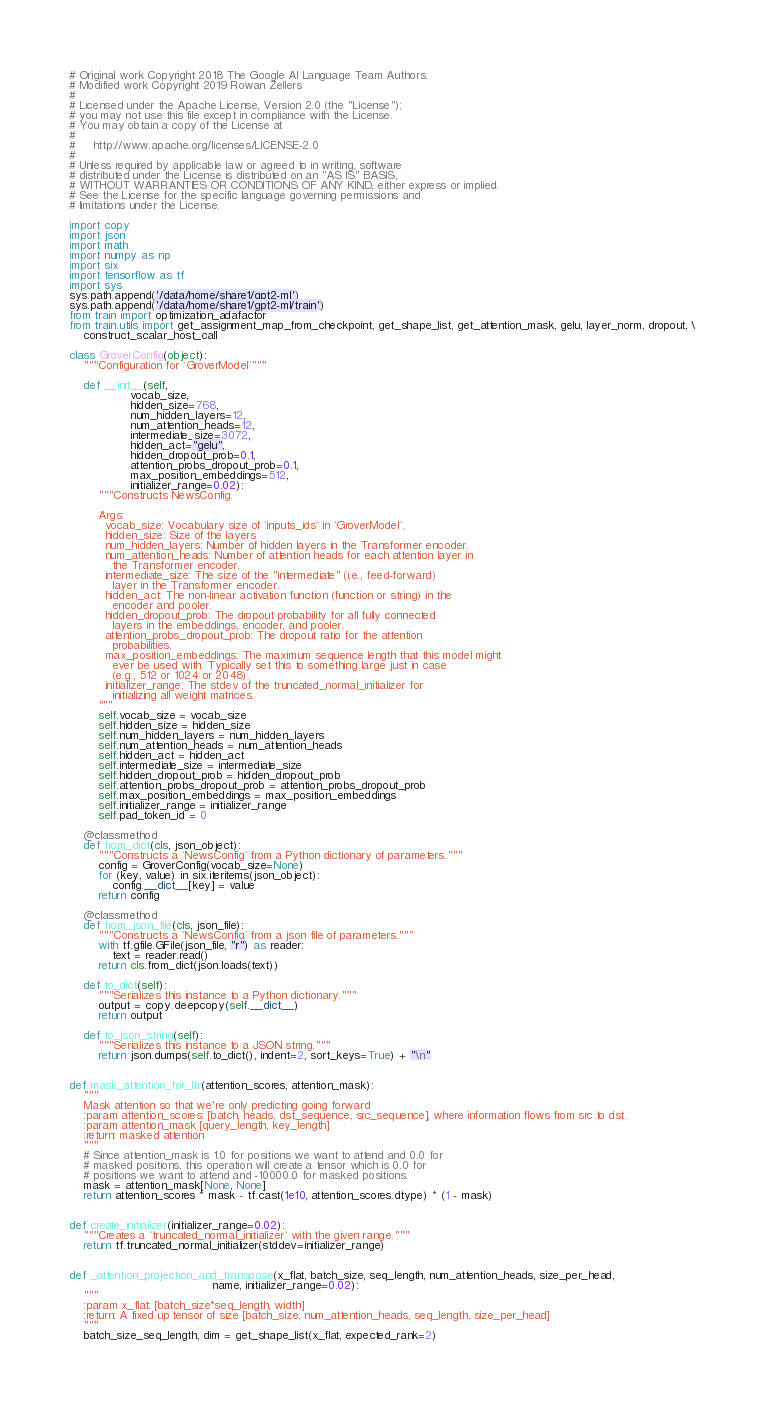Convert code to text. <code><loc_0><loc_0><loc_500><loc_500><_Python_># Original work Copyright 2018 The Google AI Language Team Authors.
# Modified work Copyright 2019 Rowan Zellers
#
# Licensed under the Apache License, Version 2.0 (the "License");
# you may not use this file except in compliance with the License.
# You may obtain a copy of the License at
#
#     http://www.apache.org/licenses/LICENSE-2.0
#
# Unless required by applicable law or agreed to in writing, software
# distributed under the License is distributed on an "AS IS" BASIS,
# WITHOUT WARRANTIES OR CONDITIONS OF ANY KIND, either express or implied.
# See the License for the specific language governing permissions and
# limitations under the License.

import copy
import json
import math
import numpy as np
import six
import tensorflow as tf
import sys
sys.path.append('/data/home/share1/gpt2-ml')
sys.path.append('/data/home/share1/gpt2-ml/train')
from train import optimization_adafactor
from train.utils import get_assignment_map_from_checkpoint, get_shape_list, get_attention_mask, gelu, layer_norm, dropout, \
    construct_scalar_host_call

class GroverConfig(object):
    """Configuration for `GroverModel`"""

    def __init__(self,
                 vocab_size,
                 hidden_size=768,
                 num_hidden_layers=12,
                 num_attention_heads=12,
                 intermediate_size=3072,
                 hidden_act="gelu",
                 hidden_dropout_prob=0.1,
                 attention_probs_dropout_prob=0.1,
                 max_position_embeddings=512,
                 initializer_range=0.02):
        """Constructs NewsConfig.

        Args:
          vocab_size: Vocabulary size of `inputs_ids` in `GroverModel`.
          hidden_size: Size of the layers
          num_hidden_layers: Number of hidden layers in the Transformer encoder.
          num_attention_heads: Number of attention heads for each attention layer in
            the Transformer encoder.
          intermediate_size: The size of the "intermediate" (i.e., feed-forward)
            layer in the Transformer encoder.
          hidden_act: The non-linear activation function (function or string) in the
            encoder and pooler.
          hidden_dropout_prob: The dropout probability for all fully connected
            layers in the embeddings, encoder, and pooler.
          attention_probs_dropout_prob: The dropout ratio for the attention
            probabilities.
          max_position_embeddings: The maximum sequence length that this model might
            ever be used with. Typically set this to something large just in case
            (e.g., 512 or 1024 or 2048).
          initializer_range: The stdev of the truncated_normal_initializer for
            initializing all weight matrices.
        """
        self.vocab_size = vocab_size
        self.hidden_size = hidden_size
        self.num_hidden_layers = num_hidden_layers
        self.num_attention_heads = num_attention_heads
        self.hidden_act = hidden_act
        self.intermediate_size = intermediate_size
        self.hidden_dropout_prob = hidden_dropout_prob
        self.attention_probs_dropout_prob = attention_probs_dropout_prob
        self.max_position_embeddings = max_position_embeddings
        self.initializer_range = initializer_range
        self.pad_token_id = 0

    @classmethod
    def from_dict(cls, json_object):
        """Constructs a `NewsConfig` from a Python dictionary of parameters."""
        config = GroverConfig(vocab_size=None)
        for (key, value) in six.iteritems(json_object):
            config.__dict__[key] = value
        return config

    @classmethod
    def from_json_file(cls, json_file):
        """Constructs a `NewsConfig` from a json file of parameters."""
        with tf.gfile.GFile(json_file, "r") as reader:
            text = reader.read()
        return cls.from_dict(json.loads(text))

    def to_dict(self):
        """Serializes this instance to a Python dictionary."""
        output = copy.deepcopy(self.__dict__)
        return output

    def to_json_string(self):
        """Serializes this instance to a JSON string."""
        return json.dumps(self.to_dict(), indent=2, sort_keys=True) + "\n"


def mask_attention_for_ltr(attention_scores, attention_mask):
    """
    Mask attention so that we're only predicting going forward
    :param attention_scores: [batch, heads, dst_sequence, src_sequence], where information flows from src to dst.
    :param attention_mask [query_length, key_length]
    :return: masked attention
    """
    # Since attention_mask is 1.0 for positions we want to attend and 0.0 for
    # masked positions, this operation will create a tensor which is 0.0 for
    # positions we want to attend and -10000.0 for masked positions.
    mask = attention_mask[None, None]
    return attention_scores * mask - tf.cast(1e10, attention_scores.dtype) * (1 - mask)


def create_initializer(initializer_range=0.02):
    """Creates a `truncated_normal_initializer` with the given range."""
    return tf.truncated_normal_initializer(stddev=initializer_range)


def _attention_projection_and_transpose(x_flat, batch_size, seq_length, num_attention_heads, size_per_head,
                                        name, initializer_range=0.02):
    """
    :param x_flat: [batch_size*seq_length, width]
    :return: A fixed up tensor of size [batch_size, num_attention_heads, seq_length, size_per_head]
    """
    batch_size_seq_length, dim = get_shape_list(x_flat, expected_rank=2)
</code> 